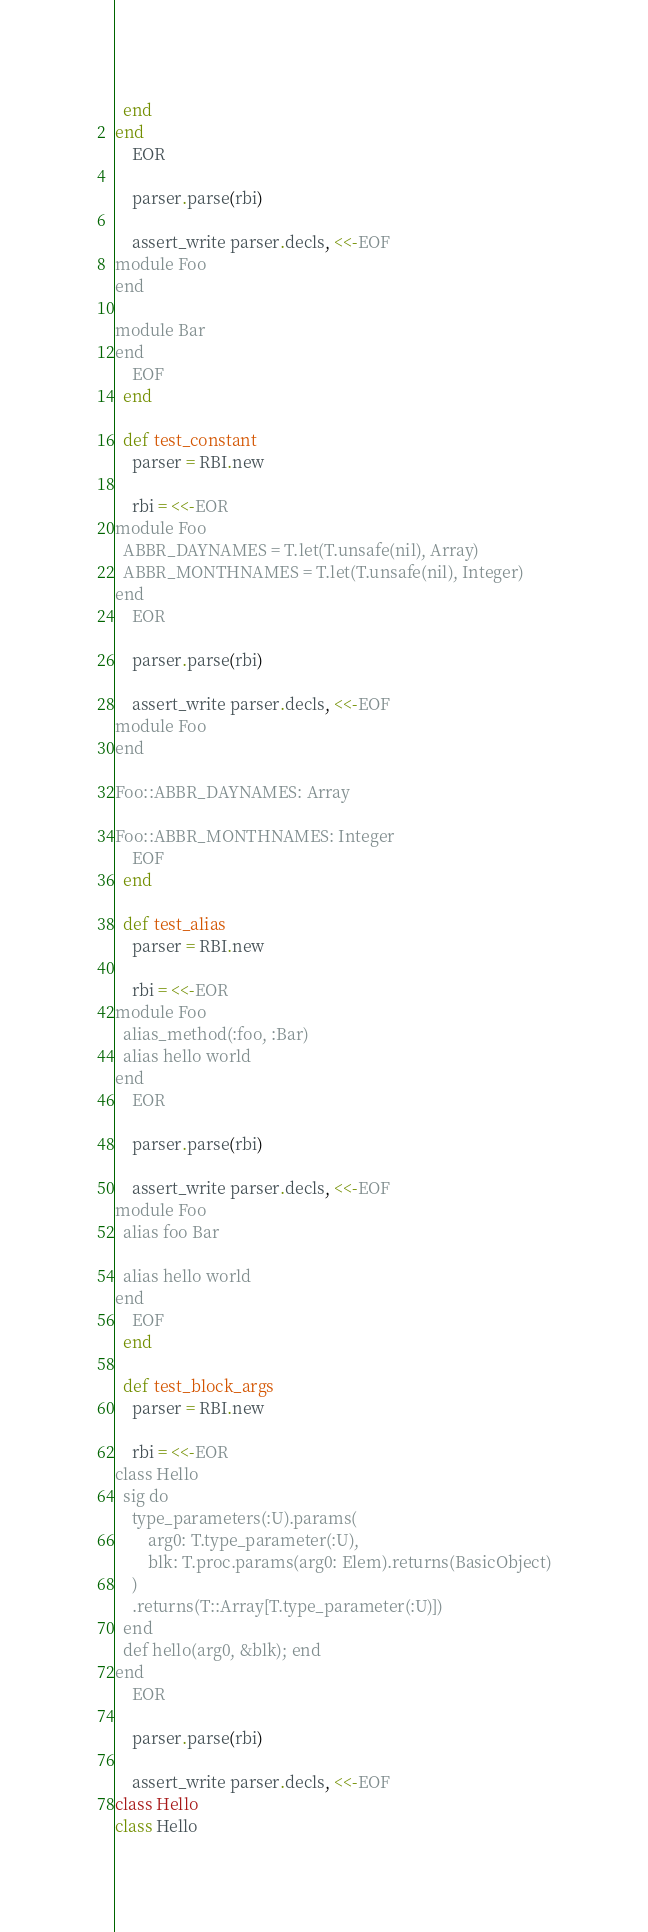<code> <loc_0><loc_0><loc_500><loc_500><_Ruby_>  end
end
    EOR

    parser.parse(rbi)

    assert_write parser.decls, <<-EOF
module Foo
end

module Bar
end
    EOF
  end

  def test_constant
    parser = RBI.new

    rbi = <<-EOR
module Foo
  ABBR_DAYNAMES = T.let(T.unsafe(nil), Array)
  ABBR_MONTHNAMES = T.let(T.unsafe(nil), Integer)
end
    EOR

    parser.parse(rbi)

    assert_write parser.decls, <<-EOF
module Foo
end

Foo::ABBR_DAYNAMES: Array

Foo::ABBR_MONTHNAMES: Integer
    EOF
  end

  def test_alias
    parser = RBI.new

    rbi = <<-EOR
module Foo
  alias_method(:foo, :Bar)
  alias hello world
end
    EOR

    parser.parse(rbi)

    assert_write parser.decls, <<-EOF
module Foo
  alias foo Bar

  alias hello world
end
    EOF
  end

  def test_block_args
    parser = RBI.new

    rbi = <<-EOR
class Hello
  sig do
    type_parameters(:U).params(
        arg0: T.type_parameter(:U),
        blk: T.proc.params(arg0: Elem).returns(BasicObject)
    )
    .returns(T::Array[T.type_parameter(:U)])
  end
  def hello(arg0, &blk); end
end
    EOR

    parser.parse(rbi)

    assert_write parser.decls, <<-EOF
class Hello</code> 